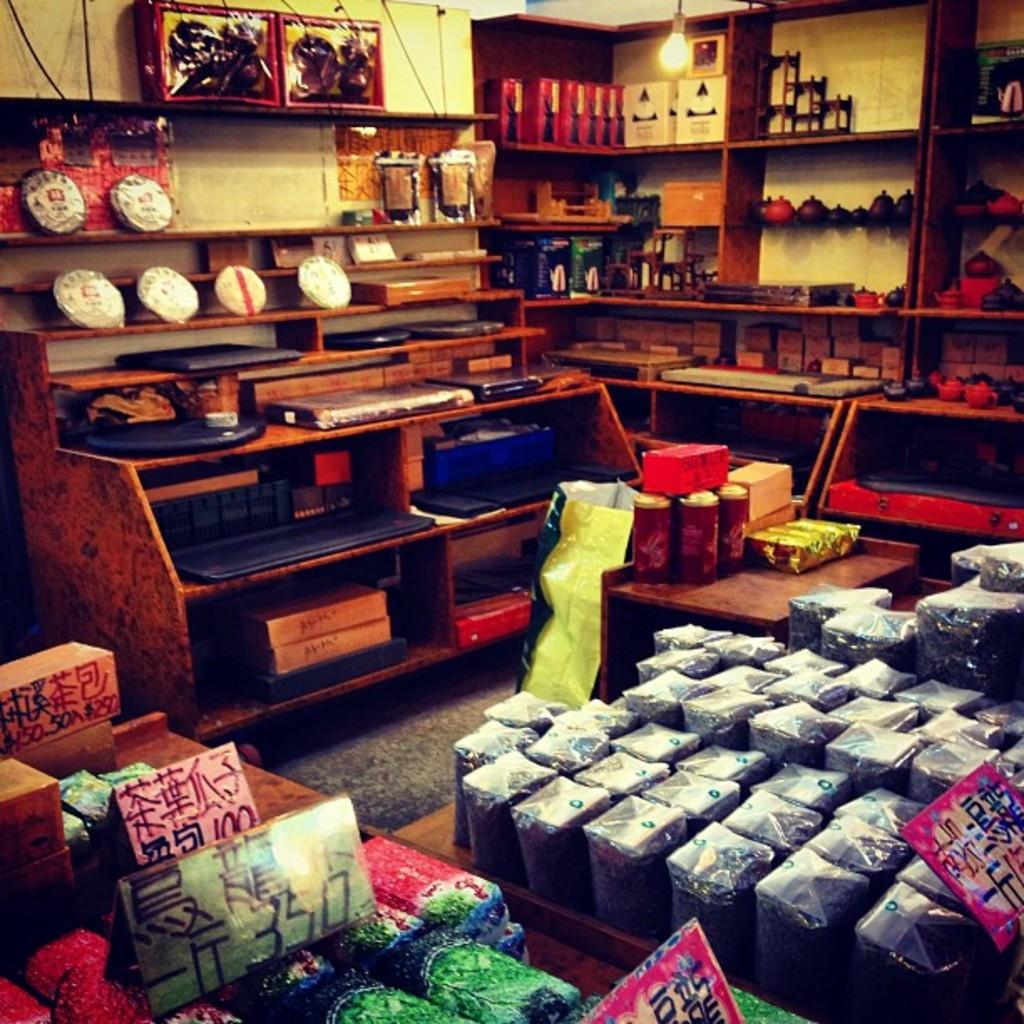<image>
Summarize the visual content of the image. A green sign on a shelf has the number 350 on it. 